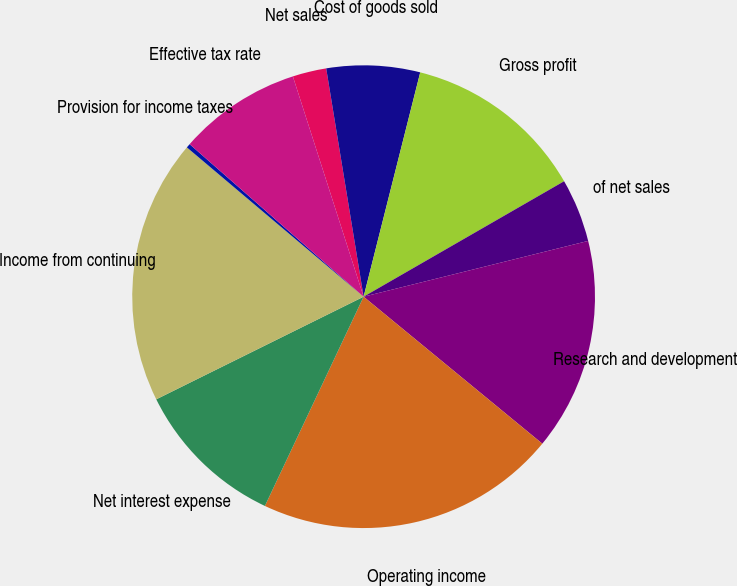<chart> <loc_0><loc_0><loc_500><loc_500><pie_chart><fcel>Net sales<fcel>Cost of goods sold<fcel>Gross profit<fcel>of net sales<fcel>Research and development<fcel>Operating income<fcel>Net interest expense<fcel>Income from continuing<fcel>Provision for income taxes<fcel>Effective tax rate<nl><fcel>2.36%<fcel>6.52%<fcel>12.75%<fcel>4.44%<fcel>14.83%<fcel>21.06%<fcel>10.67%<fcel>18.48%<fcel>0.29%<fcel>8.6%<nl></chart> 